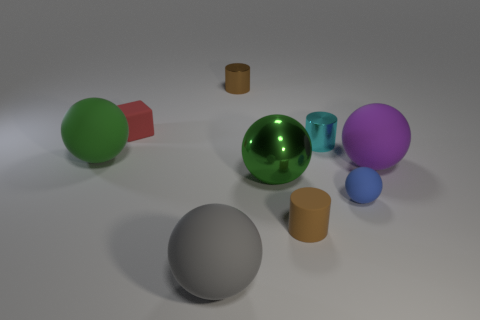Subtract all big purple spheres. How many spheres are left? 4 Subtract 1 cubes. How many cubes are left? 0 Subtract all balls. How many objects are left? 4 Add 1 yellow cylinders. How many objects exist? 10 Subtract all green things. Subtract all large purple shiny cubes. How many objects are left? 7 Add 4 brown metal cylinders. How many brown metal cylinders are left? 5 Add 2 red objects. How many red objects exist? 3 Subtract all purple spheres. How many spheres are left? 4 Subtract 0 purple blocks. How many objects are left? 9 Subtract all red balls. Subtract all gray cubes. How many balls are left? 5 